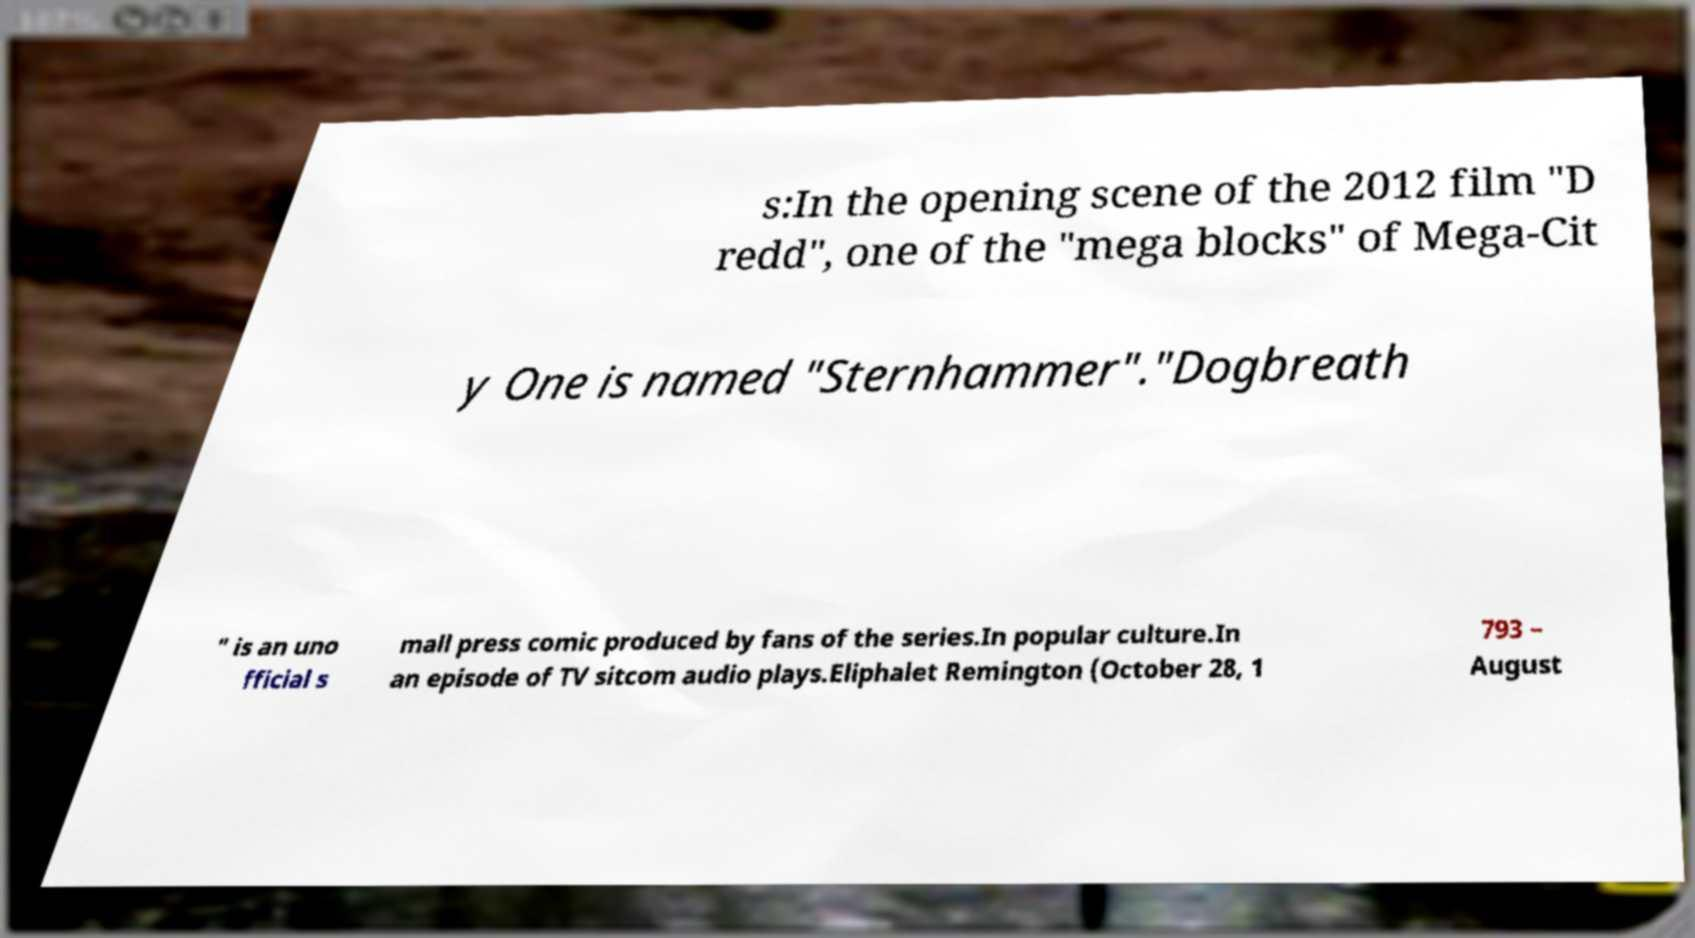There's text embedded in this image that I need extracted. Can you transcribe it verbatim? s:In the opening scene of the 2012 film "D redd", one of the "mega blocks" of Mega-Cit y One is named "Sternhammer"."Dogbreath " is an uno fficial s mall press comic produced by fans of the series.In popular culture.In an episode of TV sitcom audio plays.Eliphalet Remington (October 28, 1 793 – August 